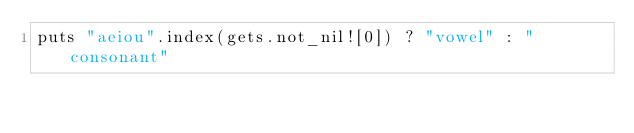<code> <loc_0><loc_0><loc_500><loc_500><_Crystal_>puts "aeiou".index(gets.not_nil![0]) ? "vowel" : "consonant"
</code> 